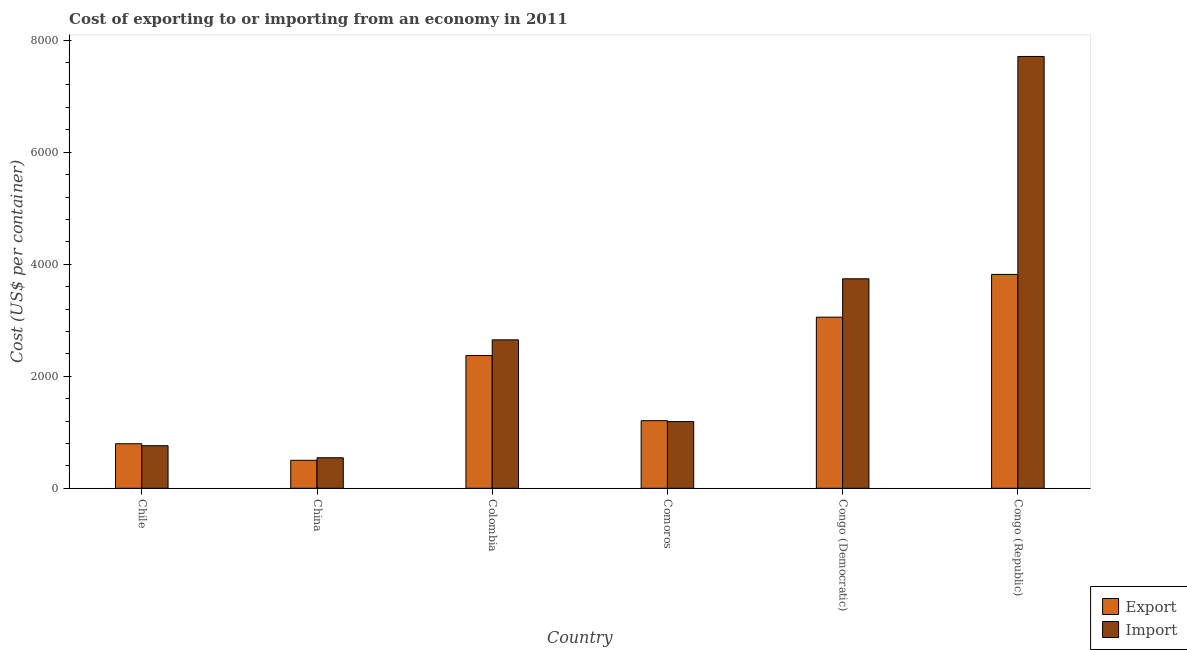How many groups of bars are there?
Your answer should be compact. 6. Are the number of bars per tick equal to the number of legend labels?
Make the answer very short. Yes. How many bars are there on the 6th tick from the left?
Make the answer very short. 2. How many bars are there on the 3rd tick from the right?
Keep it short and to the point. 2. What is the label of the 2nd group of bars from the left?
Offer a very short reply. China. In how many cases, is the number of bars for a given country not equal to the number of legend labels?
Make the answer very short. 0. What is the export cost in Congo (Republic)?
Give a very brief answer. 3818. Across all countries, what is the maximum import cost?
Ensure brevity in your answer.  7709. Across all countries, what is the minimum import cost?
Your answer should be compact. 545. In which country was the export cost maximum?
Provide a short and direct response. Congo (Republic). In which country was the import cost minimum?
Your response must be concise. China. What is the total import cost in the graph?
Your answer should be very brief. 1.66e+04. What is the difference between the import cost in China and that in Congo (Democratic)?
Your answer should be compact. -3195. What is the difference between the export cost in Congo (Republic) and the import cost in China?
Provide a short and direct response. 3273. What is the average import cost per country?
Make the answer very short. 2765.83. What is the difference between the import cost and export cost in Colombia?
Your answer should be compact. 280. What is the ratio of the export cost in Colombia to that in Comoros?
Your answer should be compact. 1.96. Is the import cost in China less than that in Comoros?
Offer a very short reply. Yes. What is the difference between the highest and the second highest export cost?
Provide a short and direct response. 763. What is the difference between the highest and the lowest export cost?
Your response must be concise. 3318. In how many countries, is the import cost greater than the average import cost taken over all countries?
Offer a very short reply. 2. What does the 1st bar from the left in Congo (Republic) represents?
Provide a succinct answer. Export. What does the 2nd bar from the right in China represents?
Make the answer very short. Export. Are all the bars in the graph horizontal?
Provide a short and direct response. No. Where does the legend appear in the graph?
Your response must be concise. Bottom right. How are the legend labels stacked?
Ensure brevity in your answer.  Vertical. What is the title of the graph?
Ensure brevity in your answer.  Cost of exporting to or importing from an economy in 2011. Does "Age 65(male)" appear as one of the legend labels in the graph?
Ensure brevity in your answer.  No. What is the label or title of the Y-axis?
Ensure brevity in your answer.  Cost (US$ per container). What is the Cost (US$ per container) of Export in Chile?
Provide a short and direct response. 795. What is the Cost (US$ per container) in Import in Chile?
Ensure brevity in your answer.  760. What is the Cost (US$ per container) of Import in China?
Give a very brief answer. 545. What is the Cost (US$ per container) in Export in Colombia?
Your answer should be compact. 2370. What is the Cost (US$ per container) in Import in Colombia?
Give a very brief answer. 2650. What is the Cost (US$ per container) in Export in Comoros?
Provide a short and direct response. 1207. What is the Cost (US$ per container) of Import in Comoros?
Give a very brief answer. 1191. What is the Cost (US$ per container) in Export in Congo (Democratic)?
Your answer should be very brief. 3055. What is the Cost (US$ per container) in Import in Congo (Democratic)?
Ensure brevity in your answer.  3740. What is the Cost (US$ per container) of Export in Congo (Republic)?
Provide a short and direct response. 3818. What is the Cost (US$ per container) of Import in Congo (Republic)?
Your response must be concise. 7709. Across all countries, what is the maximum Cost (US$ per container) of Export?
Give a very brief answer. 3818. Across all countries, what is the maximum Cost (US$ per container) of Import?
Keep it short and to the point. 7709. Across all countries, what is the minimum Cost (US$ per container) of Export?
Keep it short and to the point. 500. Across all countries, what is the minimum Cost (US$ per container) of Import?
Keep it short and to the point. 545. What is the total Cost (US$ per container) in Export in the graph?
Provide a short and direct response. 1.17e+04. What is the total Cost (US$ per container) of Import in the graph?
Give a very brief answer. 1.66e+04. What is the difference between the Cost (US$ per container) of Export in Chile and that in China?
Offer a terse response. 295. What is the difference between the Cost (US$ per container) in Import in Chile and that in China?
Give a very brief answer. 215. What is the difference between the Cost (US$ per container) in Export in Chile and that in Colombia?
Give a very brief answer. -1575. What is the difference between the Cost (US$ per container) in Import in Chile and that in Colombia?
Provide a succinct answer. -1890. What is the difference between the Cost (US$ per container) in Export in Chile and that in Comoros?
Offer a terse response. -412. What is the difference between the Cost (US$ per container) of Import in Chile and that in Comoros?
Offer a very short reply. -431. What is the difference between the Cost (US$ per container) of Export in Chile and that in Congo (Democratic)?
Offer a terse response. -2260. What is the difference between the Cost (US$ per container) of Import in Chile and that in Congo (Democratic)?
Your response must be concise. -2980. What is the difference between the Cost (US$ per container) of Export in Chile and that in Congo (Republic)?
Offer a very short reply. -3023. What is the difference between the Cost (US$ per container) in Import in Chile and that in Congo (Republic)?
Your response must be concise. -6949. What is the difference between the Cost (US$ per container) in Export in China and that in Colombia?
Your answer should be compact. -1870. What is the difference between the Cost (US$ per container) in Import in China and that in Colombia?
Make the answer very short. -2105. What is the difference between the Cost (US$ per container) in Export in China and that in Comoros?
Offer a terse response. -707. What is the difference between the Cost (US$ per container) in Import in China and that in Comoros?
Provide a succinct answer. -646. What is the difference between the Cost (US$ per container) in Export in China and that in Congo (Democratic)?
Offer a very short reply. -2555. What is the difference between the Cost (US$ per container) in Import in China and that in Congo (Democratic)?
Give a very brief answer. -3195. What is the difference between the Cost (US$ per container) of Export in China and that in Congo (Republic)?
Ensure brevity in your answer.  -3318. What is the difference between the Cost (US$ per container) of Import in China and that in Congo (Republic)?
Give a very brief answer. -7164. What is the difference between the Cost (US$ per container) of Export in Colombia and that in Comoros?
Your answer should be compact. 1163. What is the difference between the Cost (US$ per container) in Import in Colombia and that in Comoros?
Give a very brief answer. 1459. What is the difference between the Cost (US$ per container) of Export in Colombia and that in Congo (Democratic)?
Provide a succinct answer. -685. What is the difference between the Cost (US$ per container) in Import in Colombia and that in Congo (Democratic)?
Your answer should be compact. -1090. What is the difference between the Cost (US$ per container) of Export in Colombia and that in Congo (Republic)?
Give a very brief answer. -1448. What is the difference between the Cost (US$ per container) in Import in Colombia and that in Congo (Republic)?
Offer a very short reply. -5059. What is the difference between the Cost (US$ per container) in Export in Comoros and that in Congo (Democratic)?
Provide a succinct answer. -1848. What is the difference between the Cost (US$ per container) in Import in Comoros and that in Congo (Democratic)?
Give a very brief answer. -2549. What is the difference between the Cost (US$ per container) in Export in Comoros and that in Congo (Republic)?
Make the answer very short. -2611. What is the difference between the Cost (US$ per container) in Import in Comoros and that in Congo (Republic)?
Provide a short and direct response. -6518. What is the difference between the Cost (US$ per container) of Export in Congo (Democratic) and that in Congo (Republic)?
Your response must be concise. -763. What is the difference between the Cost (US$ per container) in Import in Congo (Democratic) and that in Congo (Republic)?
Give a very brief answer. -3969. What is the difference between the Cost (US$ per container) in Export in Chile and the Cost (US$ per container) in Import in China?
Provide a succinct answer. 250. What is the difference between the Cost (US$ per container) of Export in Chile and the Cost (US$ per container) of Import in Colombia?
Give a very brief answer. -1855. What is the difference between the Cost (US$ per container) of Export in Chile and the Cost (US$ per container) of Import in Comoros?
Ensure brevity in your answer.  -396. What is the difference between the Cost (US$ per container) in Export in Chile and the Cost (US$ per container) in Import in Congo (Democratic)?
Keep it short and to the point. -2945. What is the difference between the Cost (US$ per container) in Export in Chile and the Cost (US$ per container) in Import in Congo (Republic)?
Your answer should be very brief. -6914. What is the difference between the Cost (US$ per container) of Export in China and the Cost (US$ per container) of Import in Colombia?
Provide a short and direct response. -2150. What is the difference between the Cost (US$ per container) in Export in China and the Cost (US$ per container) in Import in Comoros?
Keep it short and to the point. -691. What is the difference between the Cost (US$ per container) of Export in China and the Cost (US$ per container) of Import in Congo (Democratic)?
Your answer should be compact. -3240. What is the difference between the Cost (US$ per container) in Export in China and the Cost (US$ per container) in Import in Congo (Republic)?
Provide a succinct answer. -7209. What is the difference between the Cost (US$ per container) of Export in Colombia and the Cost (US$ per container) of Import in Comoros?
Offer a very short reply. 1179. What is the difference between the Cost (US$ per container) in Export in Colombia and the Cost (US$ per container) in Import in Congo (Democratic)?
Provide a short and direct response. -1370. What is the difference between the Cost (US$ per container) of Export in Colombia and the Cost (US$ per container) of Import in Congo (Republic)?
Provide a short and direct response. -5339. What is the difference between the Cost (US$ per container) in Export in Comoros and the Cost (US$ per container) in Import in Congo (Democratic)?
Give a very brief answer. -2533. What is the difference between the Cost (US$ per container) of Export in Comoros and the Cost (US$ per container) of Import in Congo (Republic)?
Ensure brevity in your answer.  -6502. What is the difference between the Cost (US$ per container) of Export in Congo (Democratic) and the Cost (US$ per container) of Import in Congo (Republic)?
Keep it short and to the point. -4654. What is the average Cost (US$ per container) in Export per country?
Provide a succinct answer. 1957.5. What is the average Cost (US$ per container) in Import per country?
Your answer should be very brief. 2765.83. What is the difference between the Cost (US$ per container) in Export and Cost (US$ per container) in Import in Chile?
Give a very brief answer. 35. What is the difference between the Cost (US$ per container) of Export and Cost (US$ per container) of Import in China?
Give a very brief answer. -45. What is the difference between the Cost (US$ per container) of Export and Cost (US$ per container) of Import in Colombia?
Provide a succinct answer. -280. What is the difference between the Cost (US$ per container) in Export and Cost (US$ per container) in Import in Comoros?
Offer a terse response. 16. What is the difference between the Cost (US$ per container) of Export and Cost (US$ per container) of Import in Congo (Democratic)?
Provide a succinct answer. -685. What is the difference between the Cost (US$ per container) of Export and Cost (US$ per container) of Import in Congo (Republic)?
Provide a short and direct response. -3891. What is the ratio of the Cost (US$ per container) in Export in Chile to that in China?
Provide a succinct answer. 1.59. What is the ratio of the Cost (US$ per container) of Import in Chile to that in China?
Offer a very short reply. 1.39. What is the ratio of the Cost (US$ per container) in Export in Chile to that in Colombia?
Offer a very short reply. 0.34. What is the ratio of the Cost (US$ per container) in Import in Chile to that in Colombia?
Offer a terse response. 0.29. What is the ratio of the Cost (US$ per container) of Export in Chile to that in Comoros?
Offer a terse response. 0.66. What is the ratio of the Cost (US$ per container) in Import in Chile to that in Comoros?
Provide a short and direct response. 0.64. What is the ratio of the Cost (US$ per container) in Export in Chile to that in Congo (Democratic)?
Your answer should be compact. 0.26. What is the ratio of the Cost (US$ per container) of Import in Chile to that in Congo (Democratic)?
Your answer should be compact. 0.2. What is the ratio of the Cost (US$ per container) of Export in Chile to that in Congo (Republic)?
Give a very brief answer. 0.21. What is the ratio of the Cost (US$ per container) of Import in Chile to that in Congo (Republic)?
Provide a short and direct response. 0.1. What is the ratio of the Cost (US$ per container) of Export in China to that in Colombia?
Make the answer very short. 0.21. What is the ratio of the Cost (US$ per container) in Import in China to that in Colombia?
Your answer should be compact. 0.21. What is the ratio of the Cost (US$ per container) in Export in China to that in Comoros?
Offer a very short reply. 0.41. What is the ratio of the Cost (US$ per container) in Import in China to that in Comoros?
Ensure brevity in your answer.  0.46. What is the ratio of the Cost (US$ per container) of Export in China to that in Congo (Democratic)?
Provide a succinct answer. 0.16. What is the ratio of the Cost (US$ per container) of Import in China to that in Congo (Democratic)?
Make the answer very short. 0.15. What is the ratio of the Cost (US$ per container) of Export in China to that in Congo (Republic)?
Offer a very short reply. 0.13. What is the ratio of the Cost (US$ per container) in Import in China to that in Congo (Republic)?
Ensure brevity in your answer.  0.07. What is the ratio of the Cost (US$ per container) of Export in Colombia to that in Comoros?
Make the answer very short. 1.96. What is the ratio of the Cost (US$ per container) of Import in Colombia to that in Comoros?
Your answer should be compact. 2.23. What is the ratio of the Cost (US$ per container) of Export in Colombia to that in Congo (Democratic)?
Your answer should be very brief. 0.78. What is the ratio of the Cost (US$ per container) of Import in Colombia to that in Congo (Democratic)?
Provide a succinct answer. 0.71. What is the ratio of the Cost (US$ per container) of Export in Colombia to that in Congo (Republic)?
Ensure brevity in your answer.  0.62. What is the ratio of the Cost (US$ per container) in Import in Colombia to that in Congo (Republic)?
Provide a short and direct response. 0.34. What is the ratio of the Cost (US$ per container) in Export in Comoros to that in Congo (Democratic)?
Your answer should be compact. 0.4. What is the ratio of the Cost (US$ per container) of Import in Comoros to that in Congo (Democratic)?
Your answer should be very brief. 0.32. What is the ratio of the Cost (US$ per container) of Export in Comoros to that in Congo (Republic)?
Your answer should be very brief. 0.32. What is the ratio of the Cost (US$ per container) in Import in Comoros to that in Congo (Republic)?
Offer a very short reply. 0.15. What is the ratio of the Cost (US$ per container) of Export in Congo (Democratic) to that in Congo (Republic)?
Give a very brief answer. 0.8. What is the ratio of the Cost (US$ per container) in Import in Congo (Democratic) to that in Congo (Republic)?
Make the answer very short. 0.49. What is the difference between the highest and the second highest Cost (US$ per container) of Export?
Provide a succinct answer. 763. What is the difference between the highest and the second highest Cost (US$ per container) in Import?
Keep it short and to the point. 3969. What is the difference between the highest and the lowest Cost (US$ per container) in Export?
Provide a short and direct response. 3318. What is the difference between the highest and the lowest Cost (US$ per container) of Import?
Give a very brief answer. 7164. 